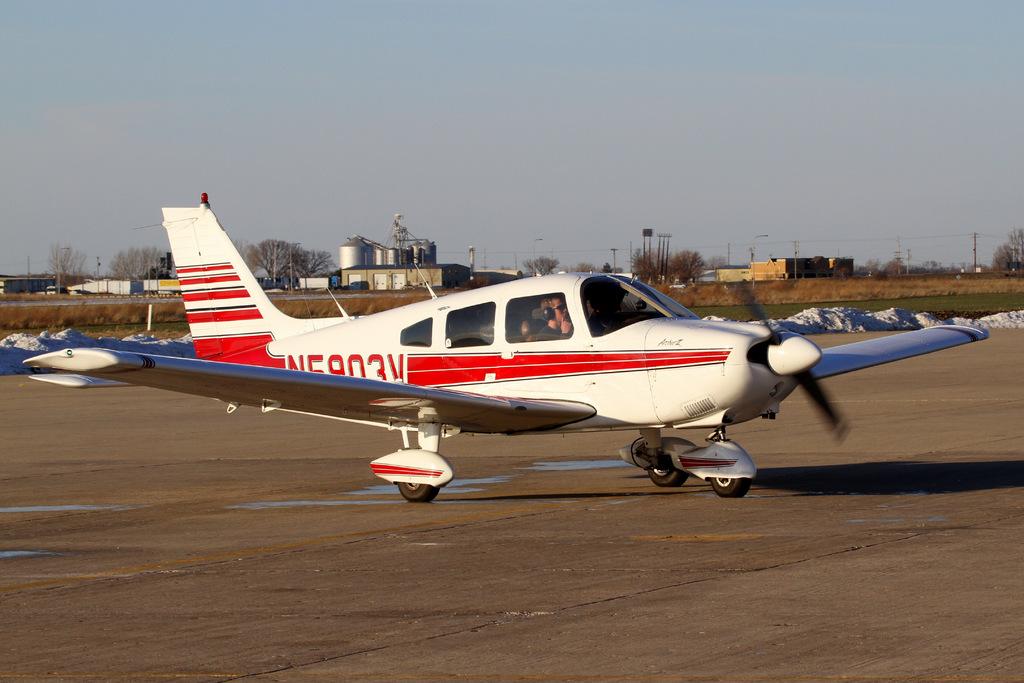What is the last number of the plane?
Offer a terse response. 3. 